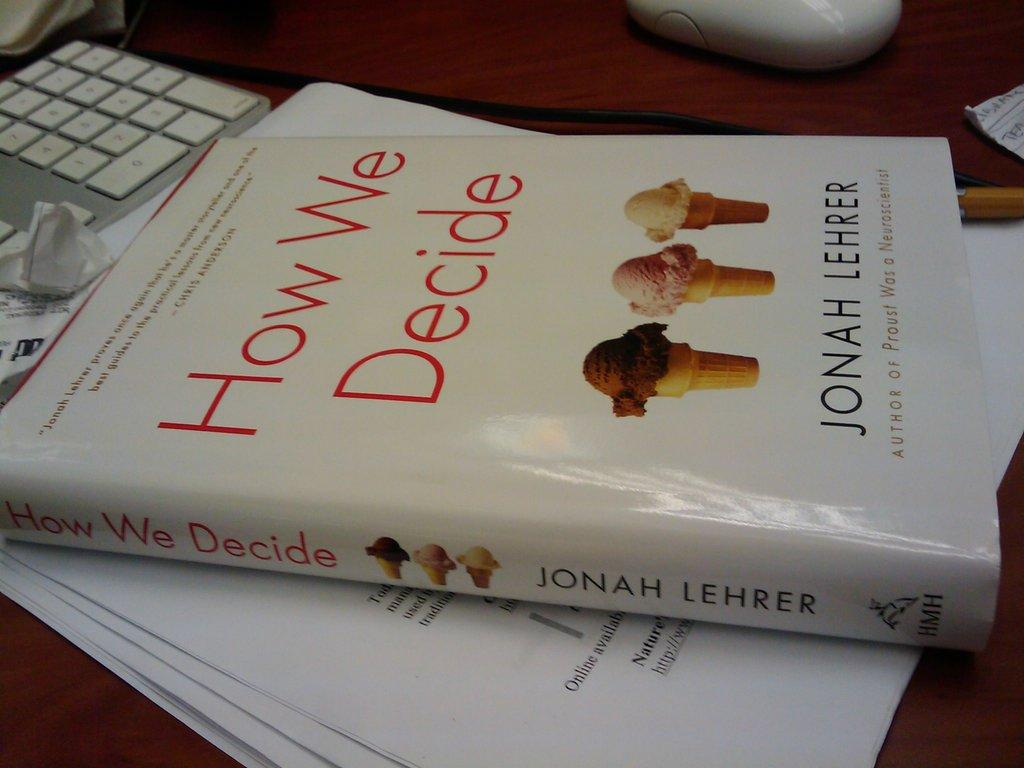Provide a one-sentence caption for the provided image. Chapter book about how we decide by Jonah Lehrer. 